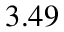<formula> <loc_0><loc_0><loc_500><loc_500>3 . 4 9</formula> 